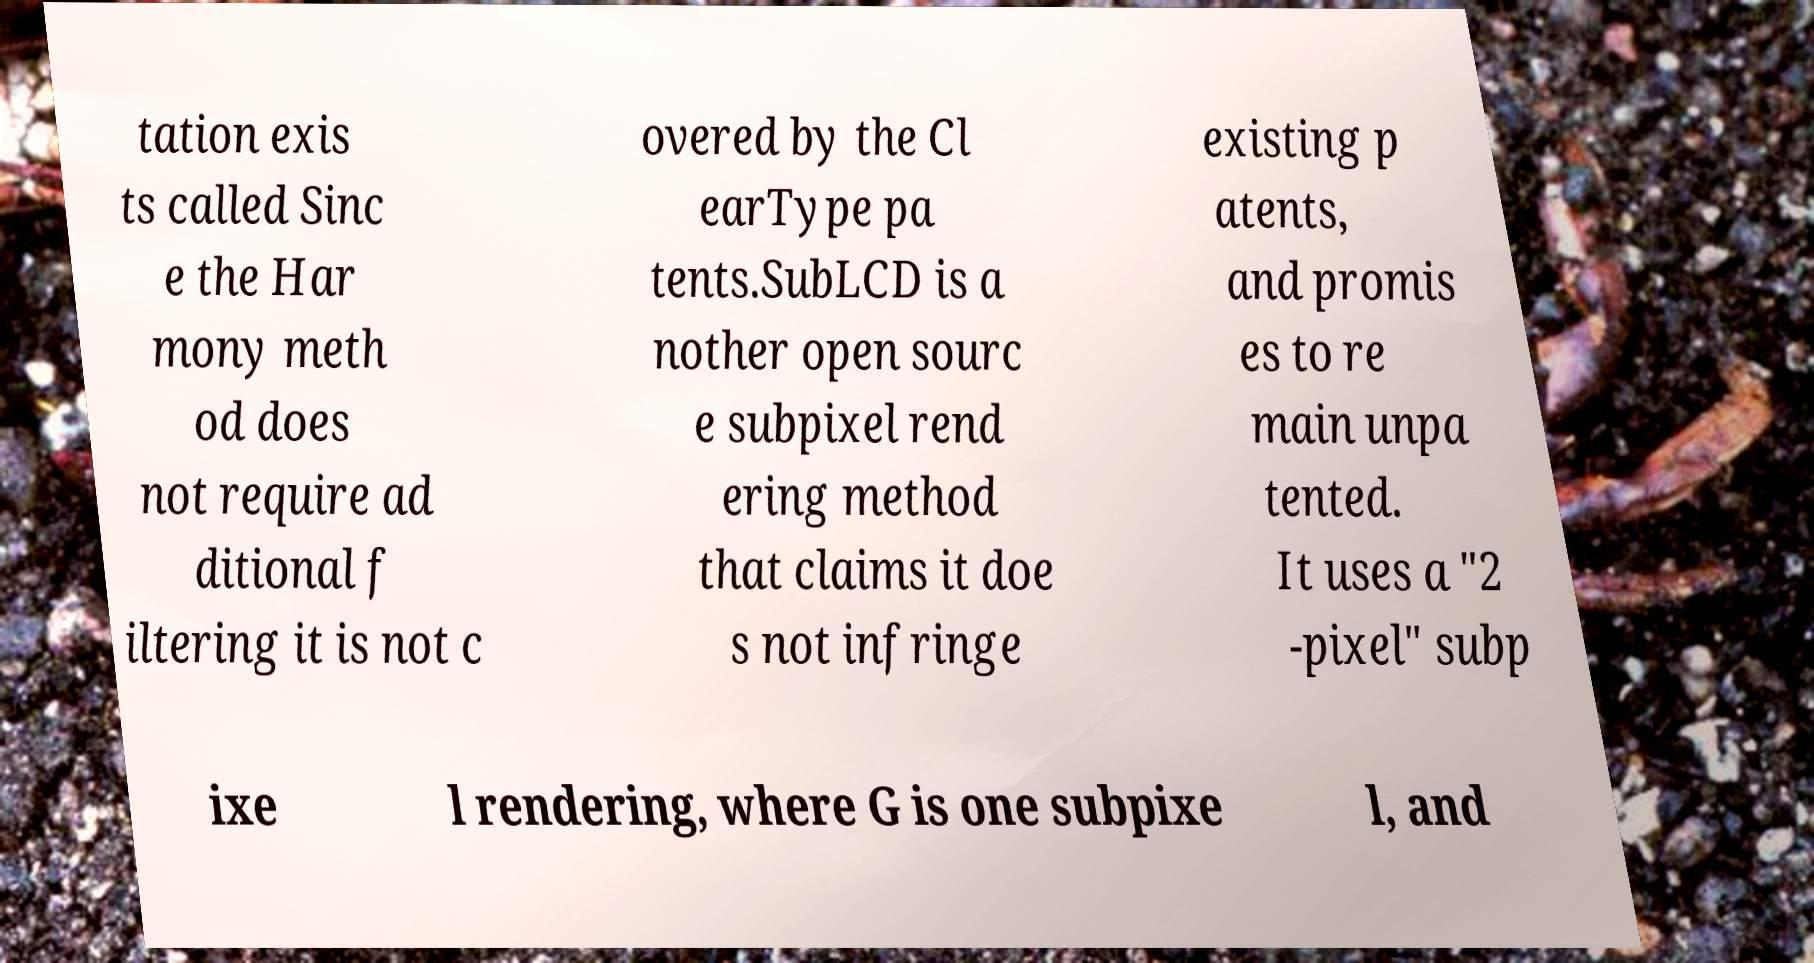I need the written content from this picture converted into text. Can you do that? tation exis ts called Sinc e the Har mony meth od does not require ad ditional f iltering it is not c overed by the Cl earType pa tents.SubLCD is a nother open sourc e subpixel rend ering method that claims it doe s not infringe existing p atents, and promis es to re main unpa tented. It uses a "2 -pixel" subp ixe l rendering, where G is one subpixe l, and 